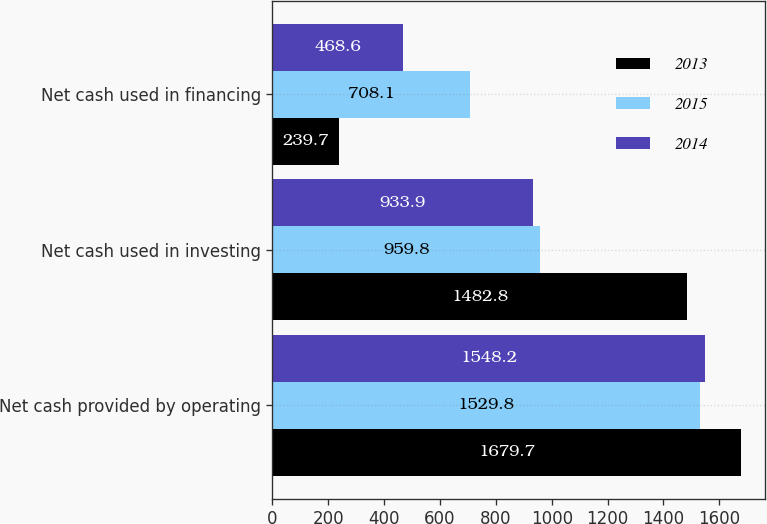Convert chart. <chart><loc_0><loc_0><loc_500><loc_500><stacked_bar_chart><ecel><fcel>Net cash provided by operating<fcel>Net cash used in investing<fcel>Net cash used in financing<nl><fcel>2013<fcel>1679.7<fcel>1482.8<fcel>239.7<nl><fcel>2015<fcel>1529.8<fcel>959.8<fcel>708.1<nl><fcel>2014<fcel>1548.2<fcel>933.9<fcel>468.6<nl></chart> 